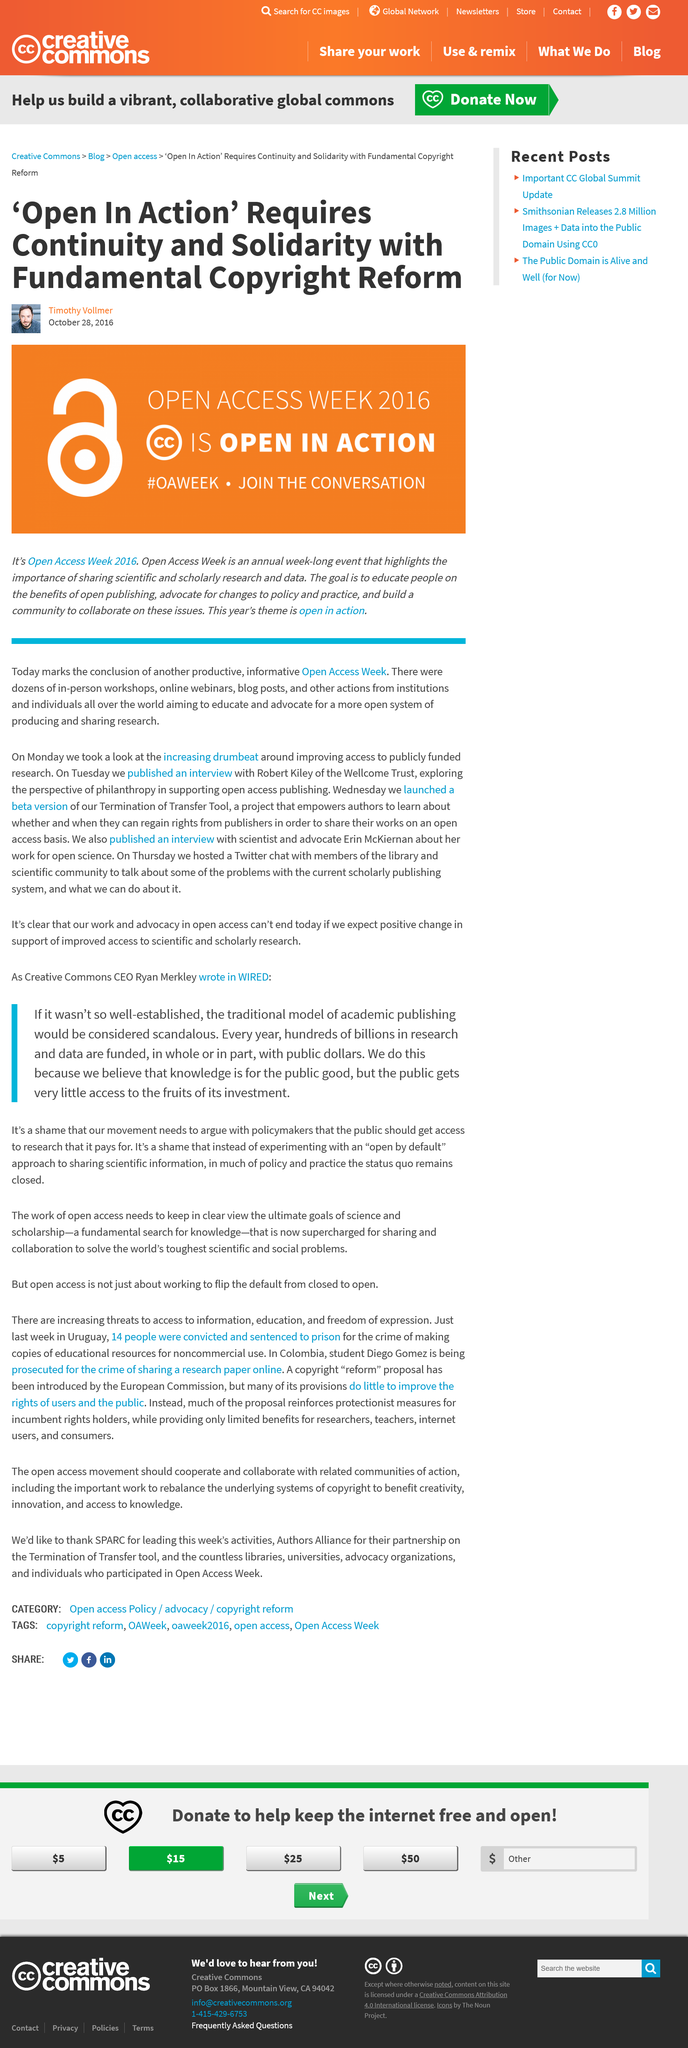Identify some key points in this picture. The slogan 'Open for Action' is the theme for the Open Access Week 2016, which is an event focused on promoting free and unrestricted access to scholarly research and data. Open access week occurs frequently, usually once a year. The goal of Open Access Week is to educate people on the benefits and importance of open publishing. 